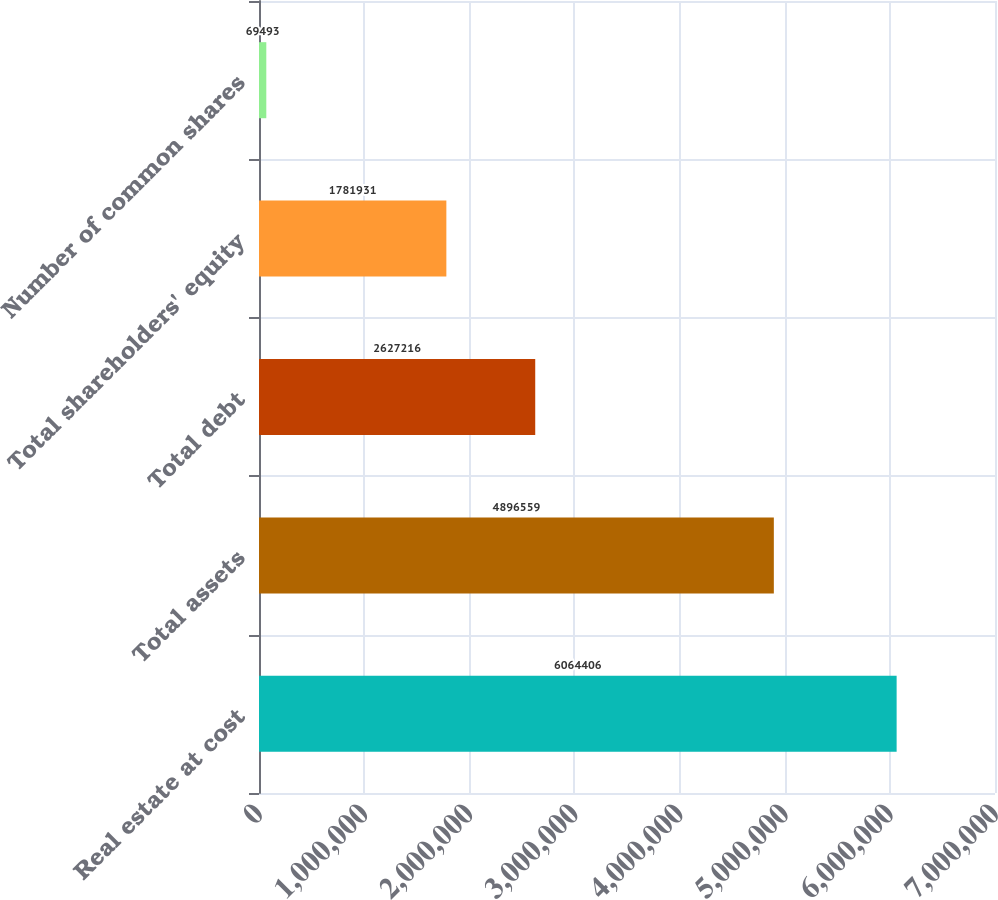Convert chart. <chart><loc_0><loc_0><loc_500><loc_500><bar_chart><fcel>Real estate at cost<fcel>Total assets<fcel>Total debt<fcel>Total shareholders' equity<fcel>Number of common shares<nl><fcel>6.06441e+06<fcel>4.89656e+06<fcel>2.62722e+06<fcel>1.78193e+06<fcel>69493<nl></chart> 